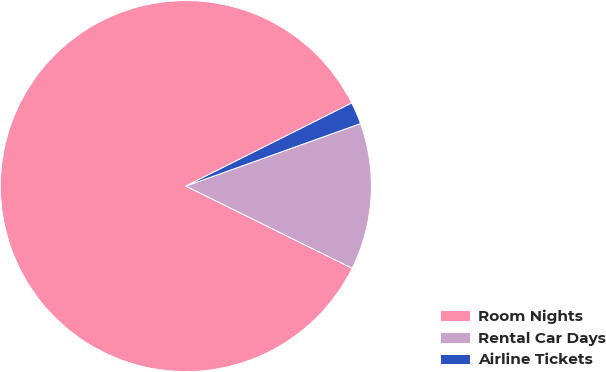<chart> <loc_0><loc_0><loc_500><loc_500><pie_chart><fcel>Room Nights<fcel>Rental Car Days<fcel>Airline Tickets<nl><fcel>85.31%<fcel>12.77%<fcel>1.92%<nl></chart> 